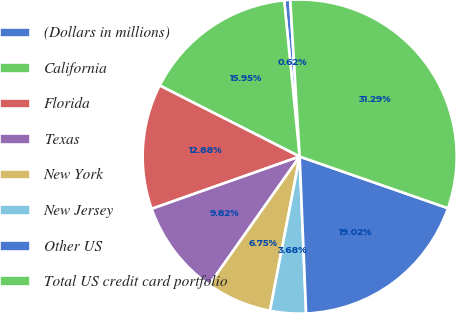<chart> <loc_0><loc_0><loc_500><loc_500><pie_chart><fcel>(Dollars in millions)<fcel>California<fcel>Florida<fcel>Texas<fcel>New York<fcel>New Jersey<fcel>Other US<fcel>Total US credit card portfolio<nl><fcel>0.62%<fcel>15.95%<fcel>12.88%<fcel>9.82%<fcel>6.75%<fcel>3.68%<fcel>19.02%<fcel>31.29%<nl></chart> 